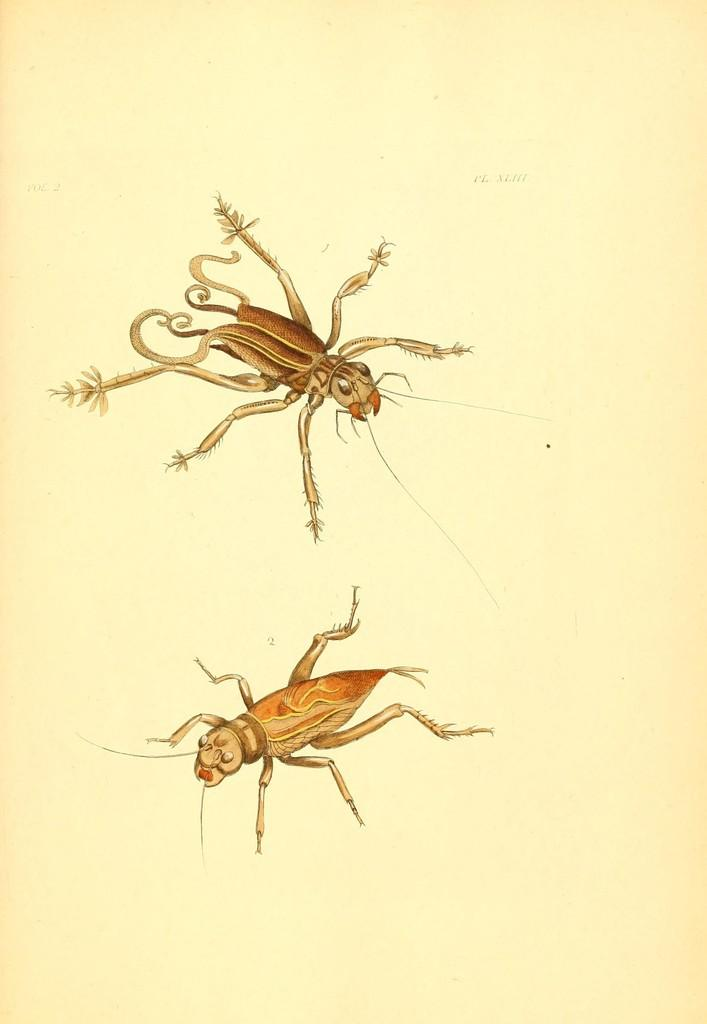What is depicted in the image? There is a drawing of an insect in the image. What is the medium of the drawing? The drawing is on a paper. What direction is the insect facing in the drawing? The image does not provide information about the insect's direction in the drawing. 